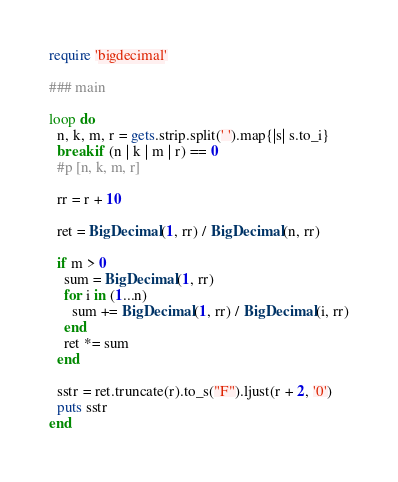Convert code to text. <code><loc_0><loc_0><loc_500><loc_500><_Ruby_>require 'bigdecimal'

### main

loop do
  n, k, m, r = gets.strip.split(' ').map{|s| s.to_i}
  break if (n | k | m | r) == 0
  #p [n, k, m, r]

  rr = r + 10

  ret = BigDecimal(1, rr) / BigDecimal(n, rr)

  if m > 0
    sum = BigDecimal(1, rr)
    for i in (1...n)
      sum += BigDecimal(1, rr) / BigDecimal(i, rr)
    end
    ret *= sum
  end

  sstr = ret.truncate(r).to_s("F").ljust(r + 2, '0')
  puts sstr
end</code> 